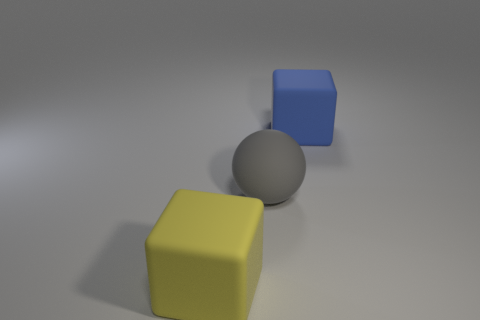Add 2 large gray matte spheres. How many objects exist? 5 Subtract all blocks. How many objects are left? 1 Subtract all gray spheres. Subtract all gray rubber things. How many objects are left? 1 Add 1 rubber things. How many rubber things are left? 4 Add 1 large gray things. How many large gray things exist? 2 Subtract 0 purple cylinders. How many objects are left? 3 